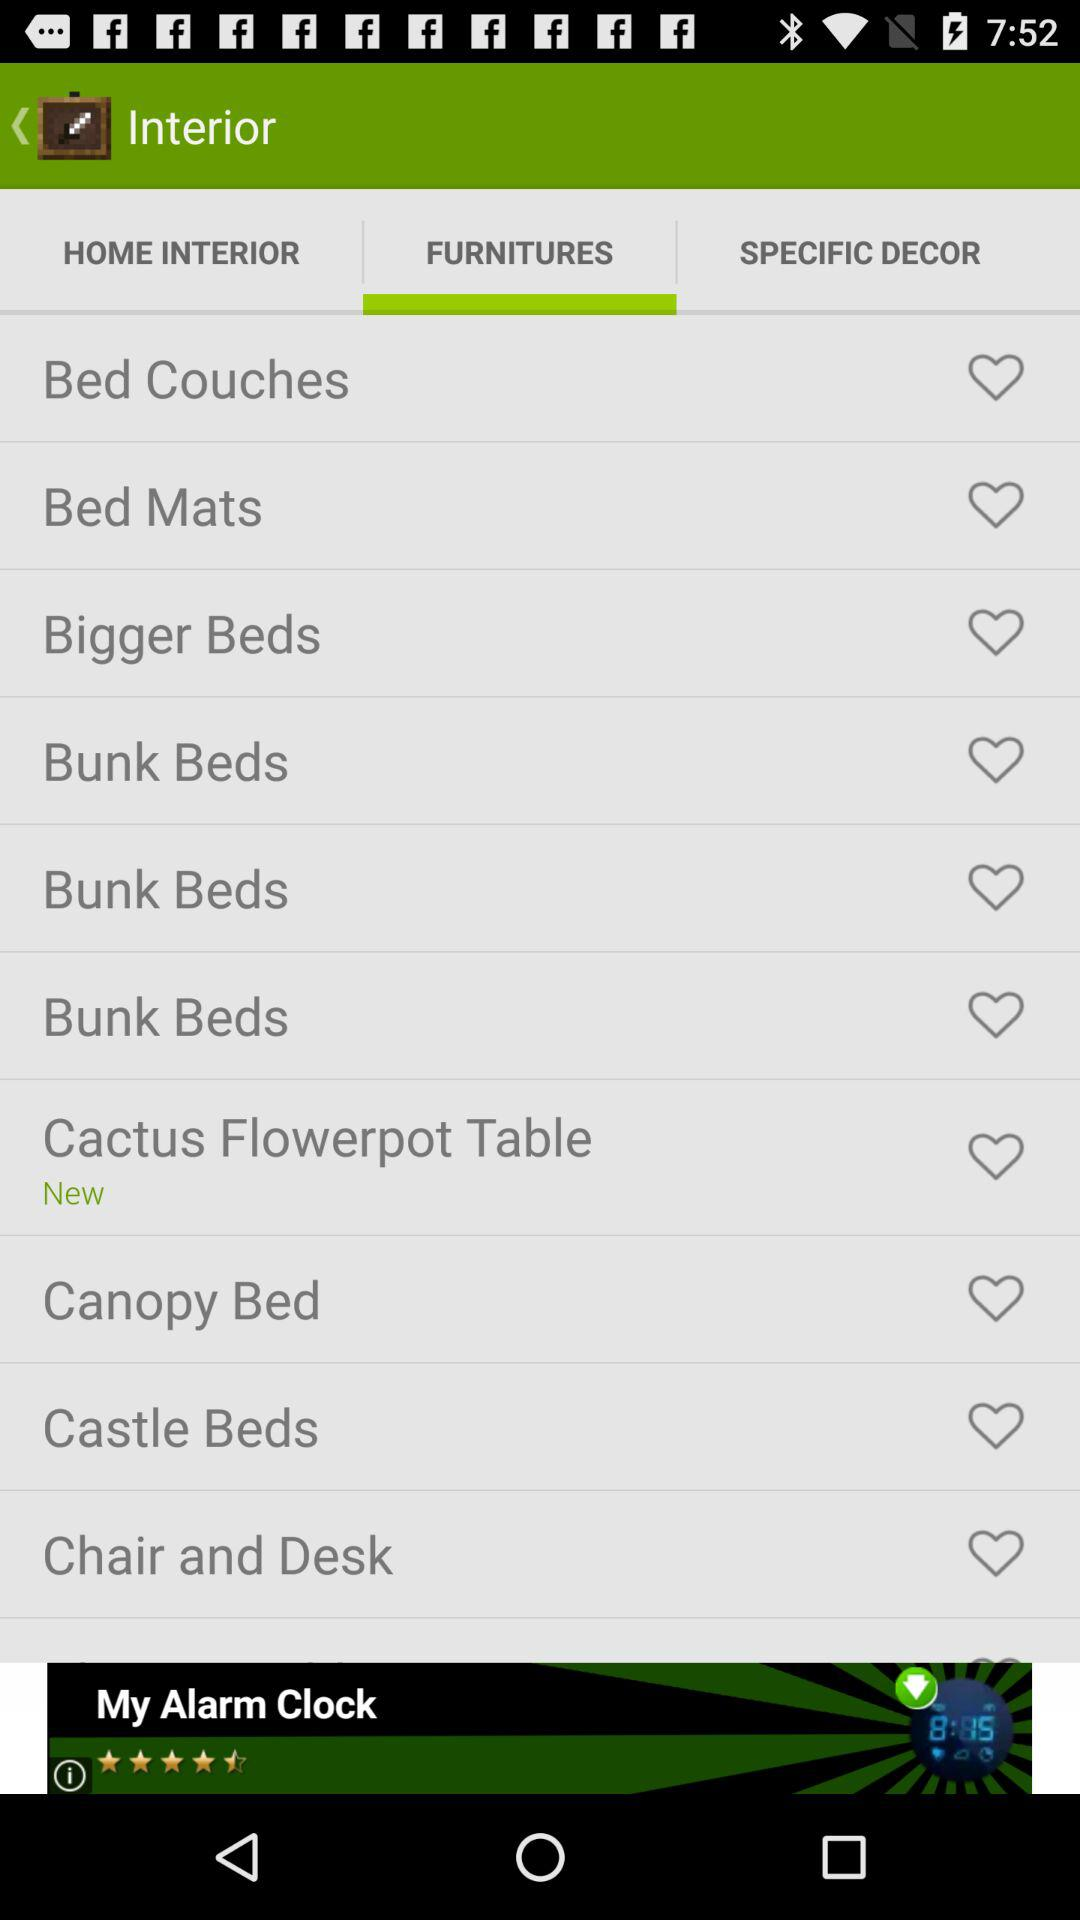Which are the different types of furniture? The different types of furniture are "Bed Couches", "Bed Mats", "Bigger Beds", "Bunk Beds", "Cactus Flowerpot Table", "Canopy Bed", "Castle Beds" and "Chair and Desk". 